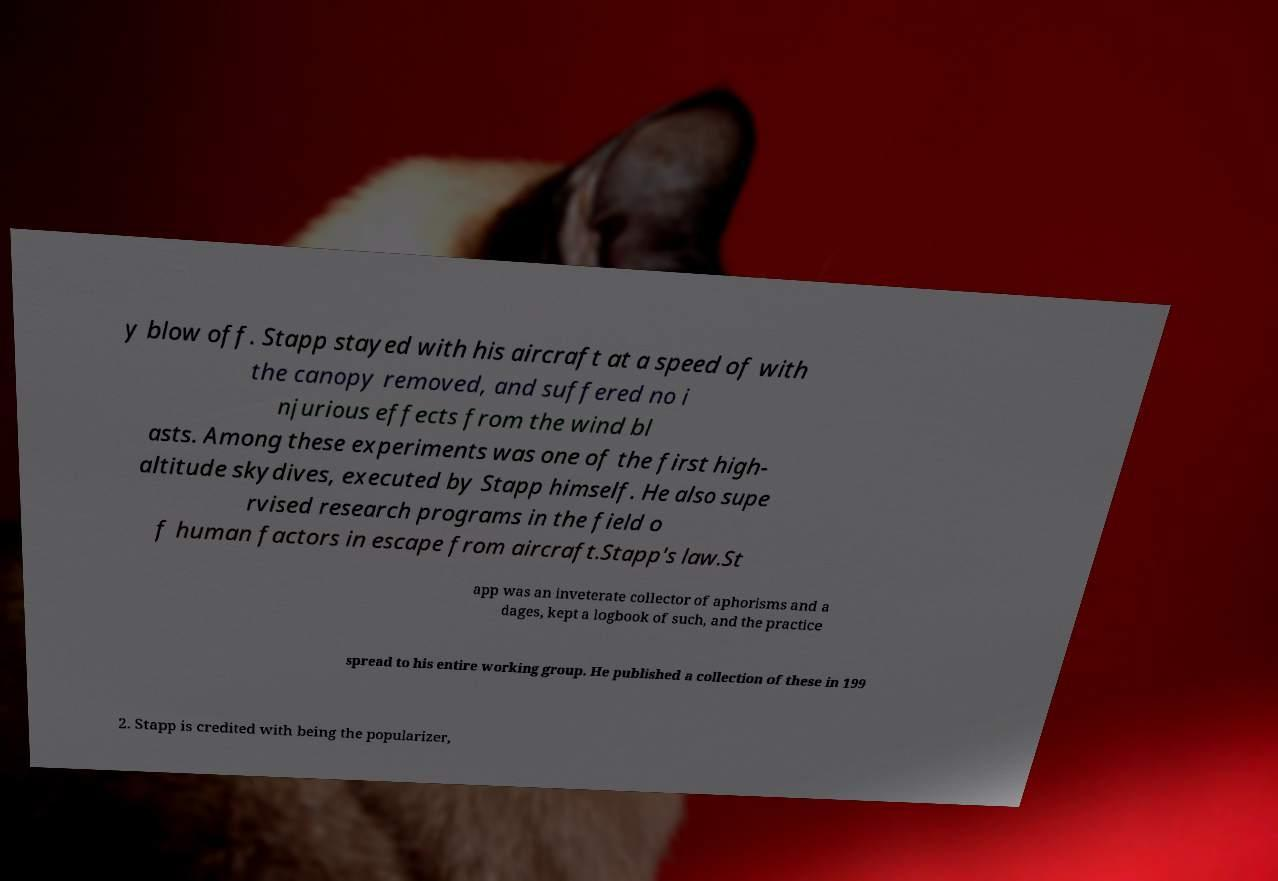What messages or text are displayed in this image? I need them in a readable, typed format. y blow off. Stapp stayed with his aircraft at a speed of with the canopy removed, and suffered no i njurious effects from the wind bl asts. Among these experiments was one of the first high- altitude skydives, executed by Stapp himself. He also supe rvised research programs in the field o f human factors in escape from aircraft.Stapp's law.St app was an inveterate collector of aphorisms and a dages, kept a logbook of such, and the practice spread to his entire working group. He published a collection of these in 199 2. Stapp is credited with being the popularizer, 